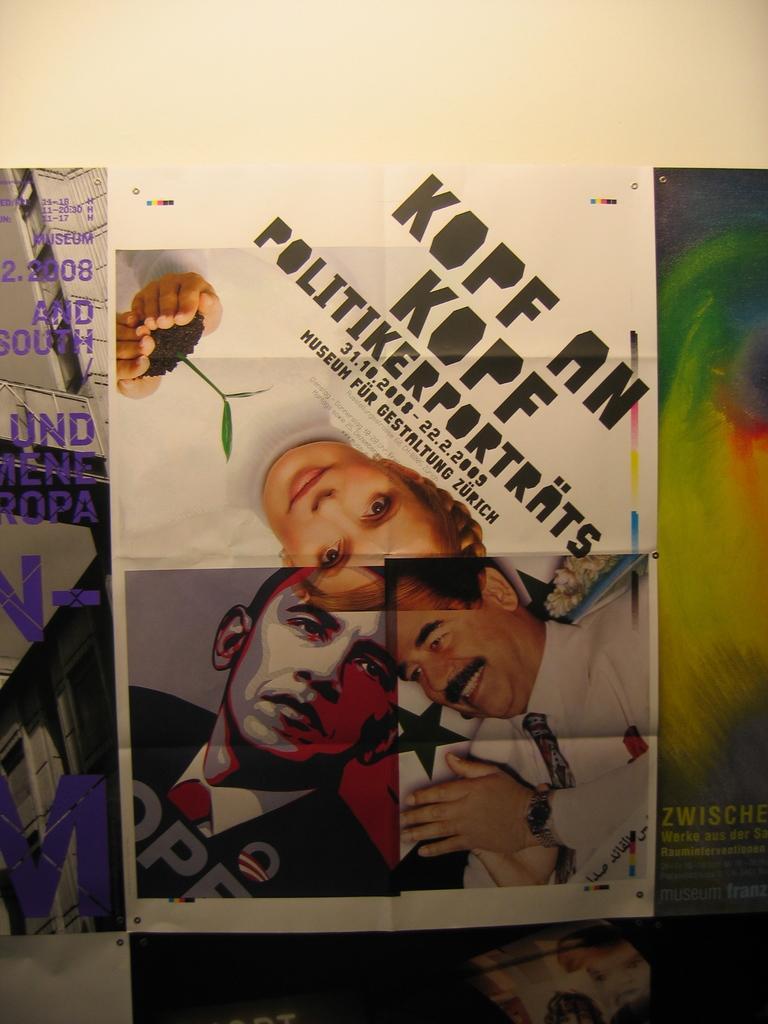In one or two sentences, can you explain what this image depicts? This image consists of a poster. On this poster I can see some text and few images of persons. 